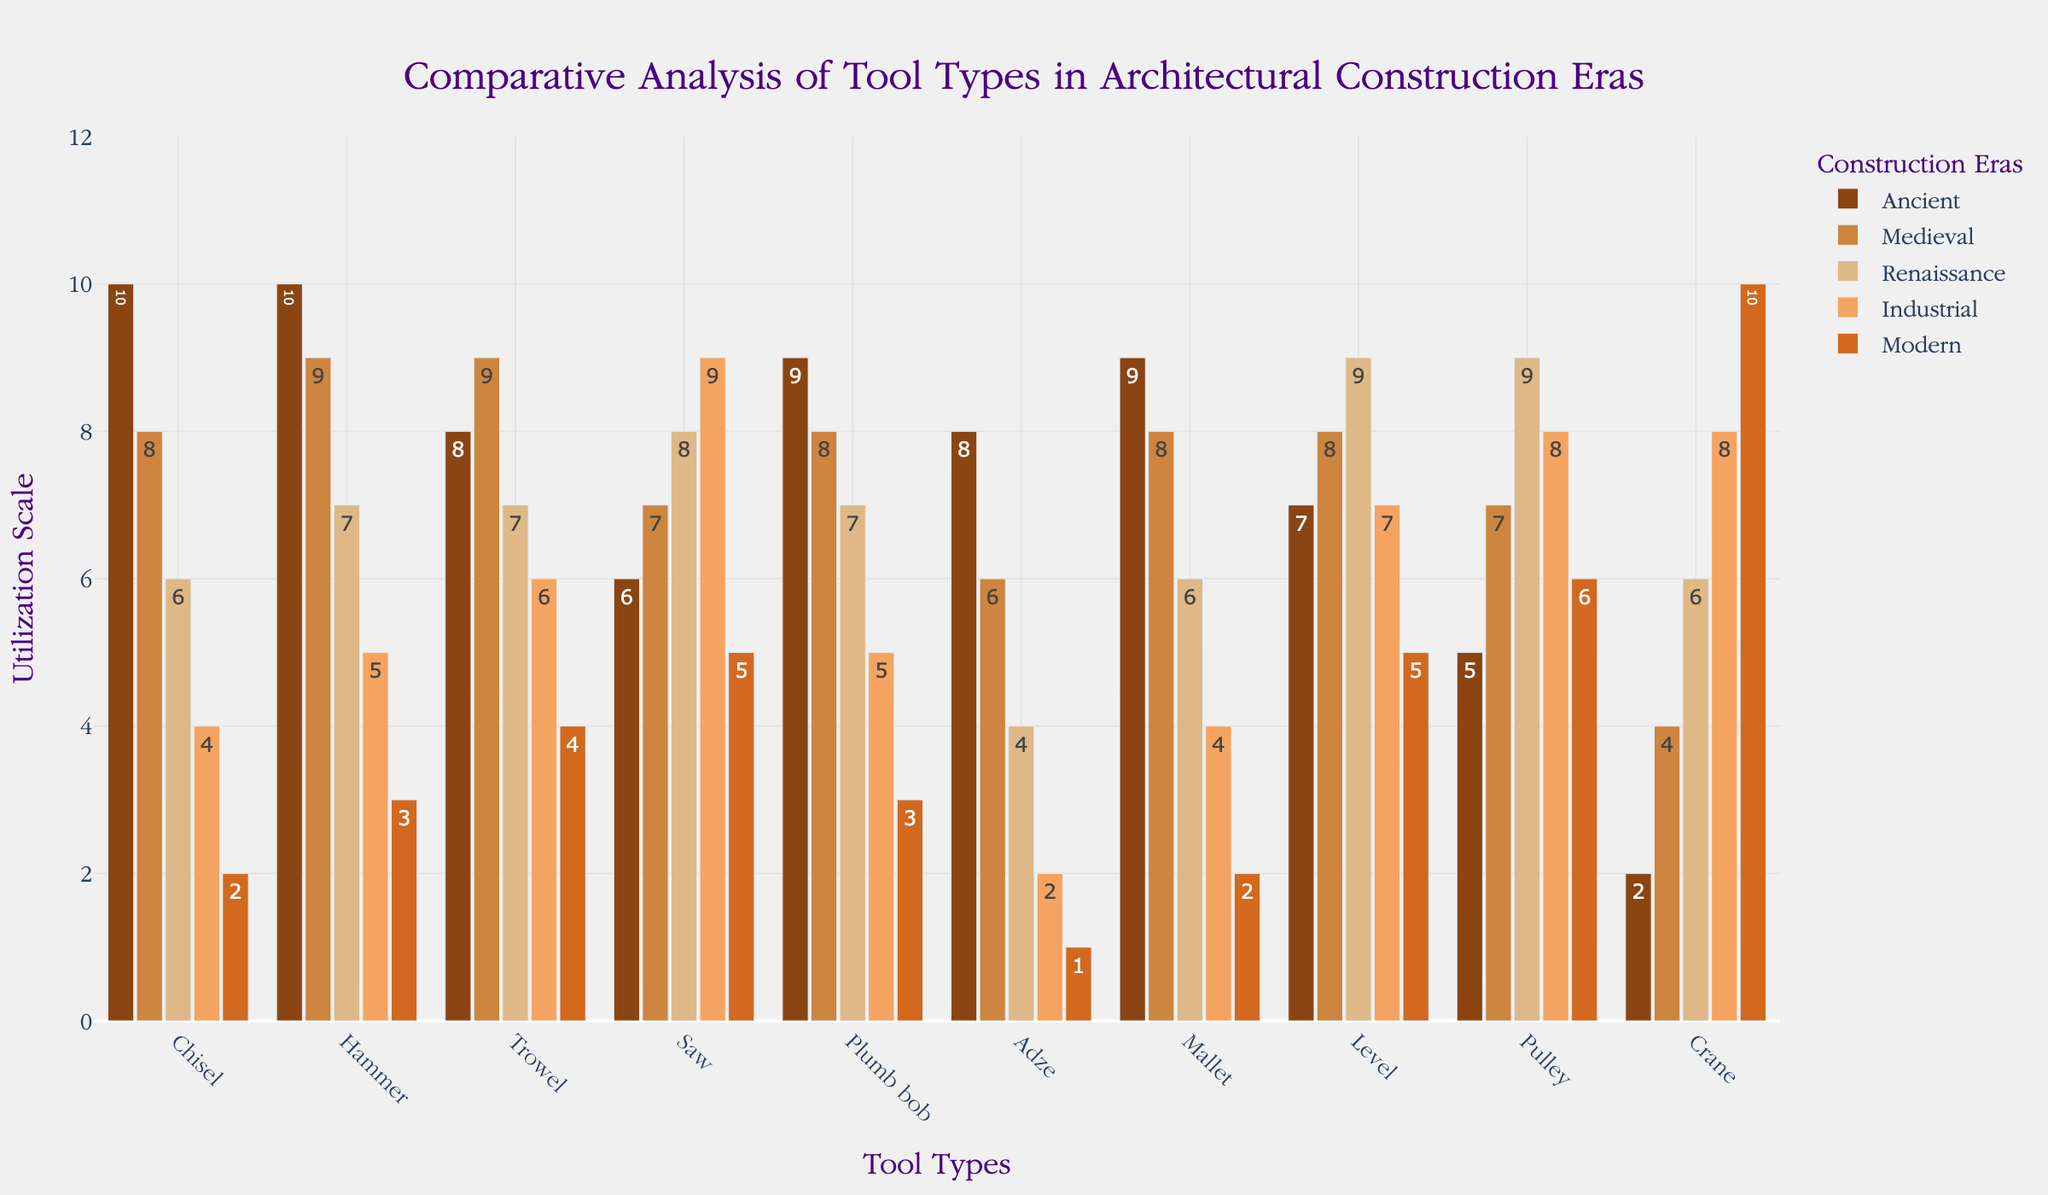What's the title of the figure? The title is often displayed prominently at the top of the figure, which helps identify the main topic or focus of the chart.
Answer: Comparative Analysis of Tool Types in Architectural Construction Eras Which tool is used the most in the Modern era? To determine which tool is used the most in the Modern era, look at the heights of the bars in the Modern era series and identify the tallest one.
Answer: Crane How many tools were used more in the Industrial era than in the Renaissance era? Count the tools that have a higher bar height in the Industrial era compared to the Renaissance era by comparing each pair of bars.
Answer: 2 (Saw and Pulley) What is the total utilization score for the Hammer across all eras? Add the utilization scores of the Hammer from all the eras: Ancient, Medieval, Renaissance, Industrial, and Modern.
Answer: 10 + 9 + 7 + 5 + 3 = 34 Which era utilizes the Chisel the least? Identify the lowest bar height for the Chisel across all eras and note which era it corresponds to.
Answer: Modern What is the average utilization of the Adze across all eras? Add the utilization scores of the Adze across all eras and then divide by the number of eras.
Answer: (8 + 6 + 4 + 2 + 1) / 5 = 21 / 5 = 4.2 Compare the utilization of the Trowel in the Medieval and Modern eras. Which one is higher and by how much? Subtract the utilization score of the Trowel in the Modern era from the score in the Medieval era.
Answer: Medieval is higher by 5 What’s the common utilization pattern of the Plumb bob and Mallet through different eras? Compare the bar heights of both tools across all eras to observe their utilization trends.
Answer: Both decline over time Identify the tool with the largest difference in utilization between any two consecutive eras. Calculate the absolute differences in utilization between consecutive eras for each tool and identify the tool with the largest difference.
Answer: Crane (difference of 2 between every era) What's the total number of bar segments displayed in the figure? Multiply the number of tools by the number of eras to find the total number of bar segments.
Answer: 10 tools * 5 eras = 50 